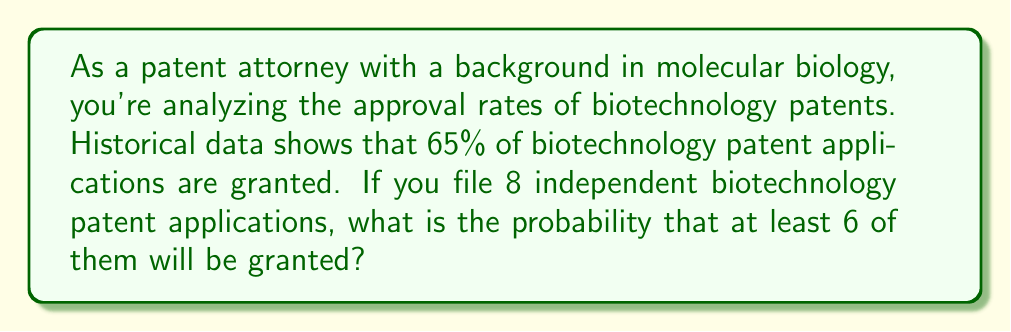Can you solve this math problem? To solve this problem, we need to use the binomial probability distribution. Let's break it down step-by-step:

1) First, let's define our variables:
   $n = 8$ (number of patent applications)
   $p = 0.65$ (probability of success for each application)
   $q = 1 - p = 0.35$ (probability of failure for each application)

2) We want to find the probability of at least 6 successes out of 8 trials. This means we need to calculate the probability of 6, 7, or 8 successes and sum them up.

3) The binomial probability formula is:

   $P(X = k) = \binom{n}{k} p^k q^{n-k}$

   where $\binom{n}{k}$ is the binomial coefficient.

4) Let's calculate each probability:

   For 6 successes: $P(X = 6) = \binom{8}{6} (0.65)^6 (0.35)^2$
   For 7 successes: $P(X = 7) = \binom{8}{7} (0.65)^7 (0.35)^1$
   For 8 successes: $P(X = 8) = \binom{8}{8} (0.65)^8 (0.35)^0$

5) Calculate the binomial coefficients:

   $\binom{8}{6} = 28$
   $\binom{8}{7} = 8$
   $\binom{8}{8} = 1$

6) Now, let's plug these values into our equation:

   $P(X \geq 6) = P(X = 6) + P(X = 7) + P(X = 8)$

   $= 28 (0.65)^6 (0.35)^2 + 8 (0.65)^7 (0.35)^1 + 1 (0.65)^8 (0.35)^0$

   $= 28 (0.075228) + 8 (0.082533) + 1 (0.018989)$

   $= 2.106384 + 0.660264 + 0.018989$

   $= 2.785637$

7) Therefore, the probability of at least 6 out of 8 patents being granted is approximately 0.2786 or 27.86%.
Answer: The probability that at least 6 out of 8 biotechnology patent applications will be granted is approximately 0.2786 or 27.86%. 